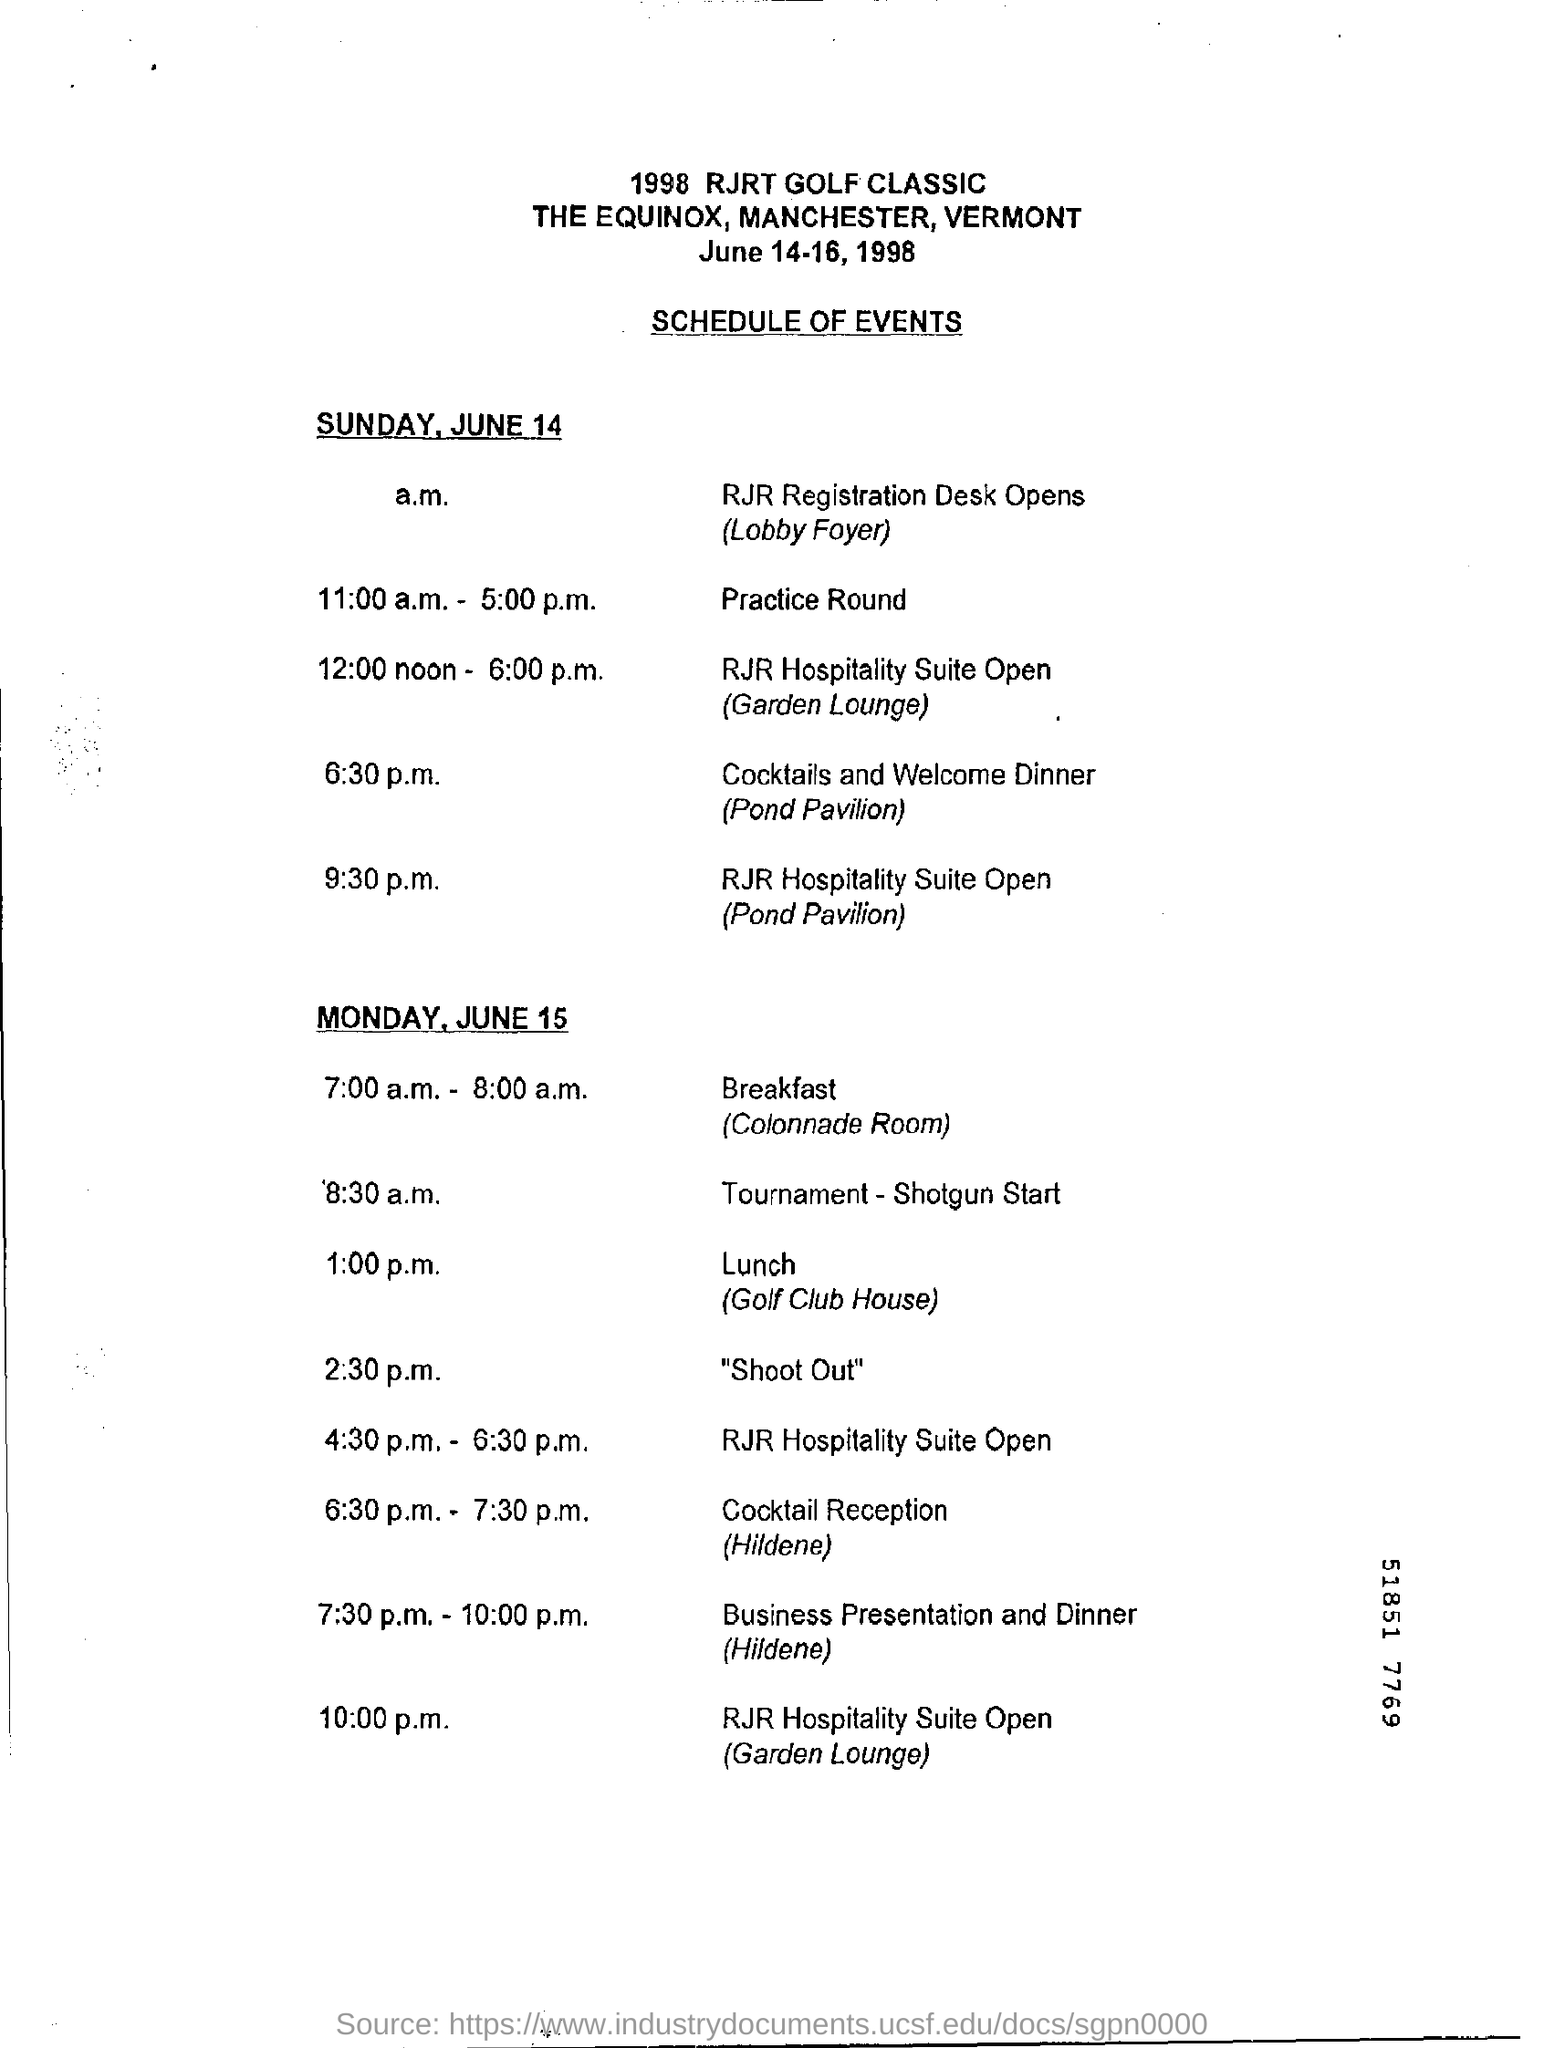What event is scheduled at 6:30 p.m. on Sunday, June 14?
Make the answer very short. Cocktails and welcome dinner. When is business presentation and dinner scheduled on Monday, June 15?
Give a very brief answer. 7:30 p.m. - 10:00 p.m. 